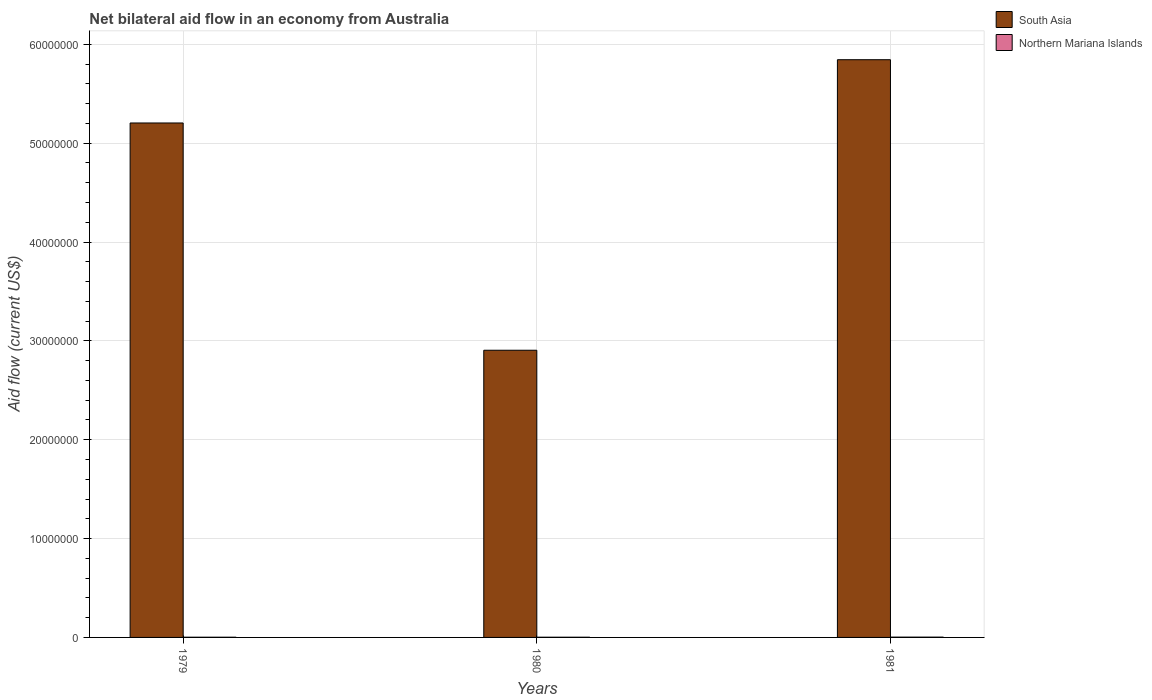In how many cases, is the number of bars for a given year not equal to the number of legend labels?
Make the answer very short. 0. Across all years, what is the minimum net bilateral aid flow in South Asia?
Your answer should be very brief. 2.90e+07. What is the total net bilateral aid flow in South Asia in the graph?
Your response must be concise. 1.40e+08. What is the difference between the net bilateral aid flow in South Asia in 1979 and that in 1981?
Give a very brief answer. -6.40e+06. What is the difference between the net bilateral aid flow in South Asia in 1980 and the net bilateral aid flow in Northern Mariana Islands in 1979?
Keep it short and to the point. 2.90e+07. What is the average net bilateral aid flow in South Asia per year?
Offer a terse response. 4.65e+07. In the year 1980, what is the difference between the net bilateral aid flow in Northern Mariana Islands and net bilateral aid flow in South Asia?
Provide a succinct answer. -2.90e+07. In how many years, is the net bilateral aid flow in South Asia greater than 16000000 US$?
Make the answer very short. 3. What is the ratio of the net bilateral aid flow in Northern Mariana Islands in 1980 to that in 1981?
Provide a short and direct response. 0.67. Is the difference between the net bilateral aid flow in Northern Mariana Islands in 1979 and 1981 greater than the difference between the net bilateral aid flow in South Asia in 1979 and 1981?
Offer a very short reply. Yes. What is the difference between the highest and the second highest net bilateral aid flow in Northern Mariana Islands?
Make the answer very short. 10000. Is the sum of the net bilateral aid flow in Northern Mariana Islands in 1980 and 1981 greater than the maximum net bilateral aid flow in South Asia across all years?
Your response must be concise. No. What does the 2nd bar from the left in 1980 represents?
Provide a short and direct response. Northern Mariana Islands. What does the 1st bar from the right in 1981 represents?
Offer a very short reply. Northern Mariana Islands. Are all the bars in the graph horizontal?
Keep it short and to the point. No. What is the difference between two consecutive major ticks on the Y-axis?
Provide a short and direct response. 1.00e+07. Are the values on the major ticks of Y-axis written in scientific E-notation?
Your response must be concise. No. Does the graph contain any zero values?
Keep it short and to the point. No. Where does the legend appear in the graph?
Keep it short and to the point. Top right. How are the legend labels stacked?
Make the answer very short. Vertical. What is the title of the graph?
Give a very brief answer. Net bilateral aid flow in an economy from Australia. What is the label or title of the X-axis?
Keep it short and to the point. Years. What is the Aid flow (current US$) of South Asia in 1979?
Offer a very short reply. 5.20e+07. What is the Aid flow (current US$) of Northern Mariana Islands in 1979?
Offer a terse response. 2.00e+04. What is the Aid flow (current US$) in South Asia in 1980?
Ensure brevity in your answer.  2.90e+07. What is the Aid flow (current US$) of Northern Mariana Islands in 1980?
Offer a very short reply. 2.00e+04. What is the Aid flow (current US$) of South Asia in 1981?
Your answer should be compact. 5.84e+07. Across all years, what is the maximum Aid flow (current US$) in South Asia?
Keep it short and to the point. 5.84e+07. Across all years, what is the maximum Aid flow (current US$) of Northern Mariana Islands?
Ensure brevity in your answer.  3.00e+04. Across all years, what is the minimum Aid flow (current US$) of South Asia?
Your response must be concise. 2.90e+07. Across all years, what is the minimum Aid flow (current US$) of Northern Mariana Islands?
Provide a succinct answer. 2.00e+04. What is the total Aid flow (current US$) in South Asia in the graph?
Keep it short and to the point. 1.40e+08. What is the difference between the Aid flow (current US$) of South Asia in 1979 and that in 1980?
Keep it short and to the point. 2.30e+07. What is the difference between the Aid flow (current US$) of South Asia in 1979 and that in 1981?
Ensure brevity in your answer.  -6.40e+06. What is the difference between the Aid flow (current US$) of South Asia in 1980 and that in 1981?
Make the answer very short. -2.94e+07. What is the difference between the Aid flow (current US$) in Northern Mariana Islands in 1980 and that in 1981?
Give a very brief answer. -10000. What is the difference between the Aid flow (current US$) of South Asia in 1979 and the Aid flow (current US$) of Northern Mariana Islands in 1980?
Offer a terse response. 5.20e+07. What is the difference between the Aid flow (current US$) in South Asia in 1979 and the Aid flow (current US$) in Northern Mariana Islands in 1981?
Offer a very short reply. 5.20e+07. What is the difference between the Aid flow (current US$) in South Asia in 1980 and the Aid flow (current US$) in Northern Mariana Islands in 1981?
Offer a very short reply. 2.90e+07. What is the average Aid flow (current US$) in South Asia per year?
Your answer should be very brief. 4.65e+07. What is the average Aid flow (current US$) in Northern Mariana Islands per year?
Your answer should be very brief. 2.33e+04. In the year 1979, what is the difference between the Aid flow (current US$) of South Asia and Aid flow (current US$) of Northern Mariana Islands?
Offer a very short reply. 5.20e+07. In the year 1980, what is the difference between the Aid flow (current US$) of South Asia and Aid flow (current US$) of Northern Mariana Islands?
Provide a short and direct response. 2.90e+07. In the year 1981, what is the difference between the Aid flow (current US$) in South Asia and Aid flow (current US$) in Northern Mariana Islands?
Give a very brief answer. 5.84e+07. What is the ratio of the Aid flow (current US$) of South Asia in 1979 to that in 1980?
Provide a succinct answer. 1.79. What is the ratio of the Aid flow (current US$) of South Asia in 1979 to that in 1981?
Ensure brevity in your answer.  0.89. What is the ratio of the Aid flow (current US$) in South Asia in 1980 to that in 1981?
Your response must be concise. 0.5. What is the ratio of the Aid flow (current US$) of Northern Mariana Islands in 1980 to that in 1981?
Your response must be concise. 0.67. What is the difference between the highest and the second highest Aid flow (current US$) in South Asia?
Ensure brevity in your answer.  6.40e+06. What is the difference between the highest and the lowest Aid flow (current US$) in South Asia?
Your answer should be very brief. 2.94e+07. What is the difference between the highest and the lowest Aid flow (current US$) of Northern Mariana Islands?
Provide a succinct answer. 10000. 